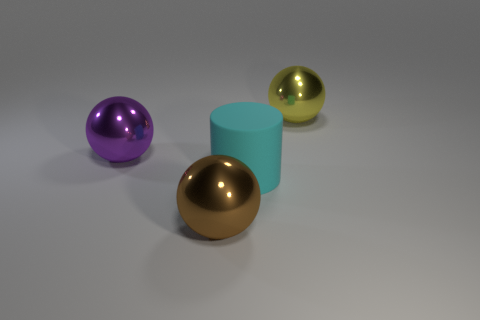Subtract all brown spheres. How many spheres are left? 2 Add 4 big cyan objects. How many objects exist? 8 Subtract all purple spheres. How many spheres are left? 2 Subtract 1 cylinders. How many cylinders are left? 0 Subtract all balls. How many objects are left? 1 Add 3 large cyan objects. How many large cyan objects are left? 4 Add 2 red things. How many red things exist? 2 Subtract 0 cyan blocks. How many objects are left? 4 Subtract all brown cylinders. Subtract all green cubes. How many cylinders are left? 1 Subtract all big gray things. Subtract all big cyan cylinders. How many objects are left? 3 